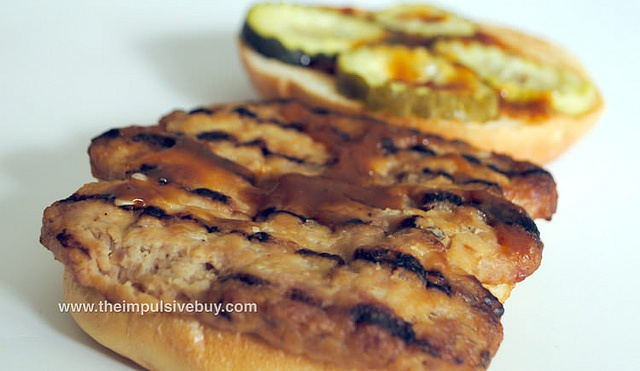Describe the objects in this image and their specific colors. I can see sandwich in lightgray, brown, and tan tones, sandwich in lightgray, khaki, olive, and tan tones, sandwich in lightgray, maroon, brown, tan, and black tones, and sandwich in lightgray, maroon, and brown tones in this image. 